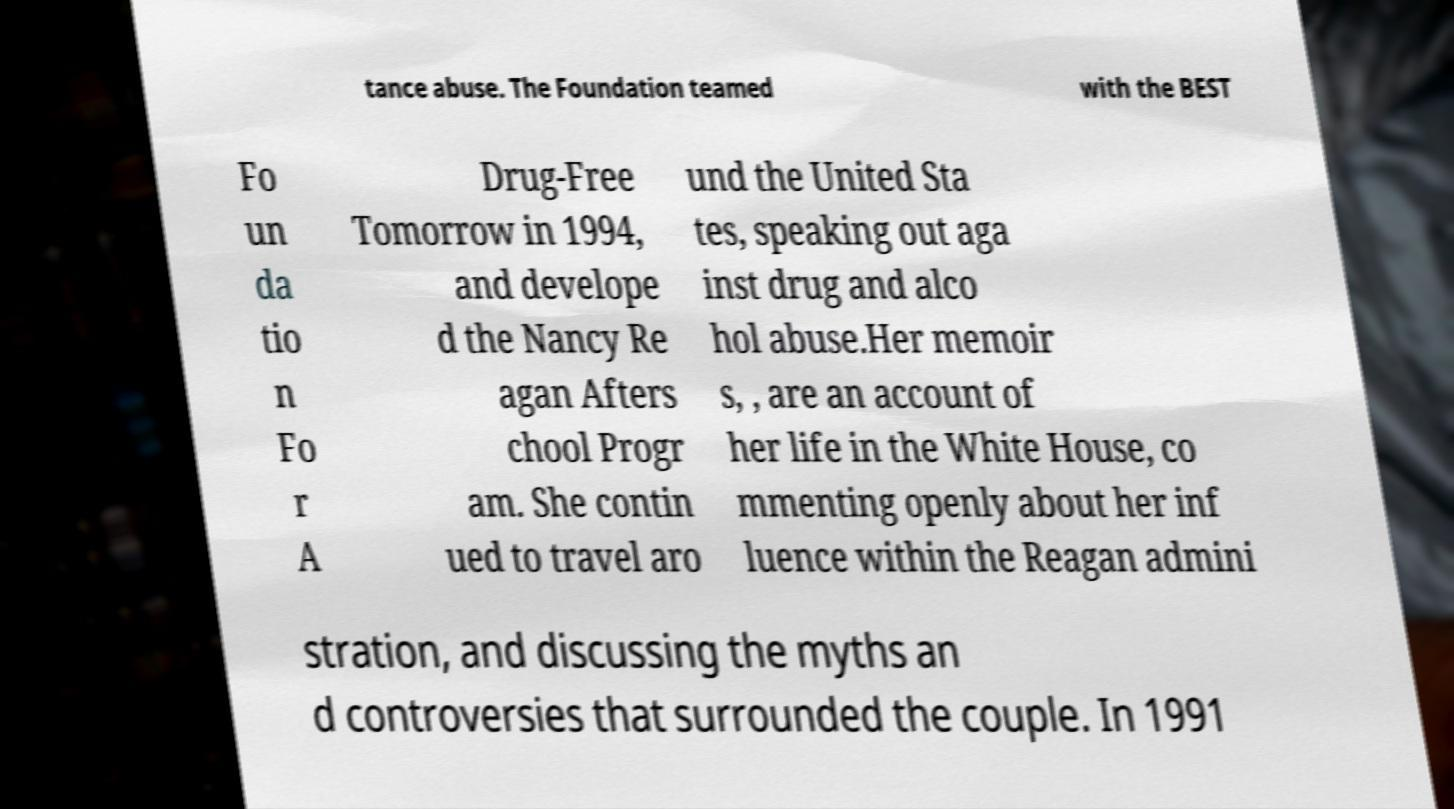I need the written content from this picture converted into text. Can you do that? tance abuse. The Foundation teamed with the BEST Fo un da tio n Fo r A Drug-Free Tomorrow in 1994, and develope d the Nancy Re agan Afters chool Progr am. She contin ued to travel aro und the United Sta tes, speaking out aga inst drug and alco hol abuse.Her memoir s, , are an account of her life in the White House, co mmenting openly about her inf luence within the Reagan admini stration, and discussing the myths an d controversies that surrounded the couple. In 1991 